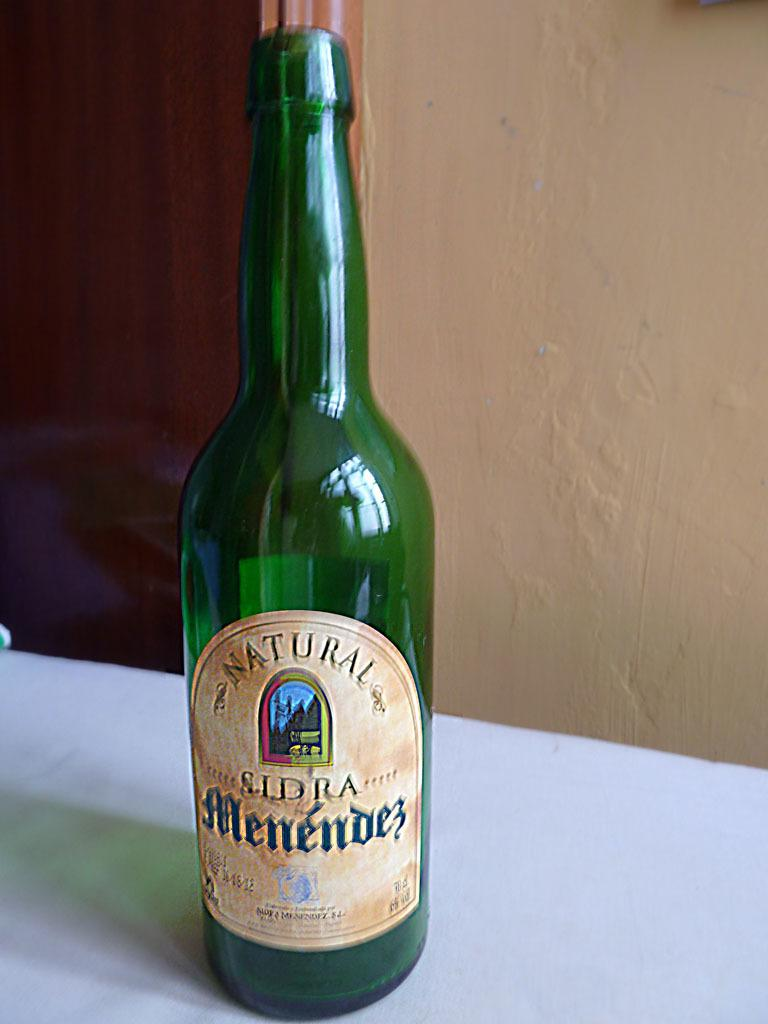<image>
Render a clear and concise summary of the photo. A beer bottle saying Natural Sldra Menendes that is green. 